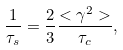Convert formula to latex. <formula><loc_0><loc_0><loc_500><loc_500>\frac { 1 } { \tau _ { s } } = \frac { 2 } { 3 } \frac { < \gamma ^ { 2 } > } { \tau _ { c } } ,</formula> 